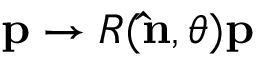Convert formula to latex. <formula><loc_0><loc_0><loc_500><loc_500>p \rightarrow R ( \hat { n } , \theta ) p</formula> 